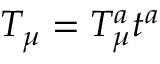Convert formula to latex. <formula><loc_0><loc_0><loc_500><loc_500>T _ { \mu } = T _ { \mu } ^ { a } t ^ { a }</formula> 